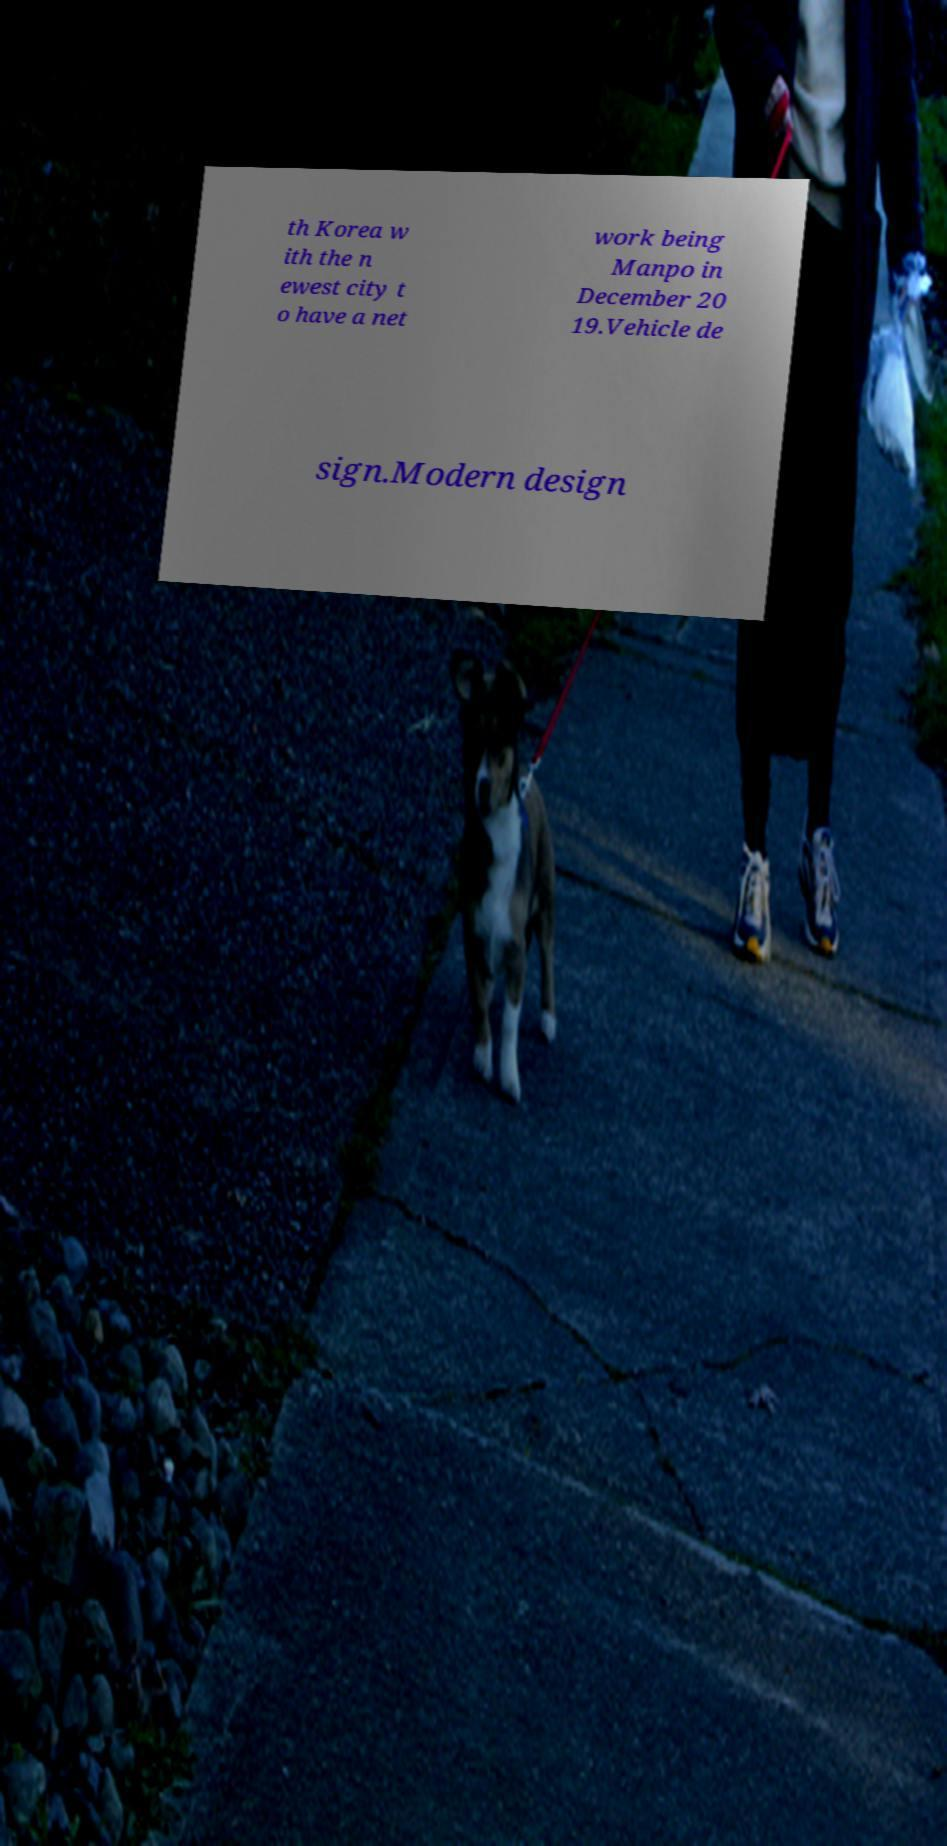Please read and relay the text visible in this image. What does it say? th Korea w ith the n ewest city t o have a net work being Manpo in December 20 19.Vehicle de sign.Modern design 